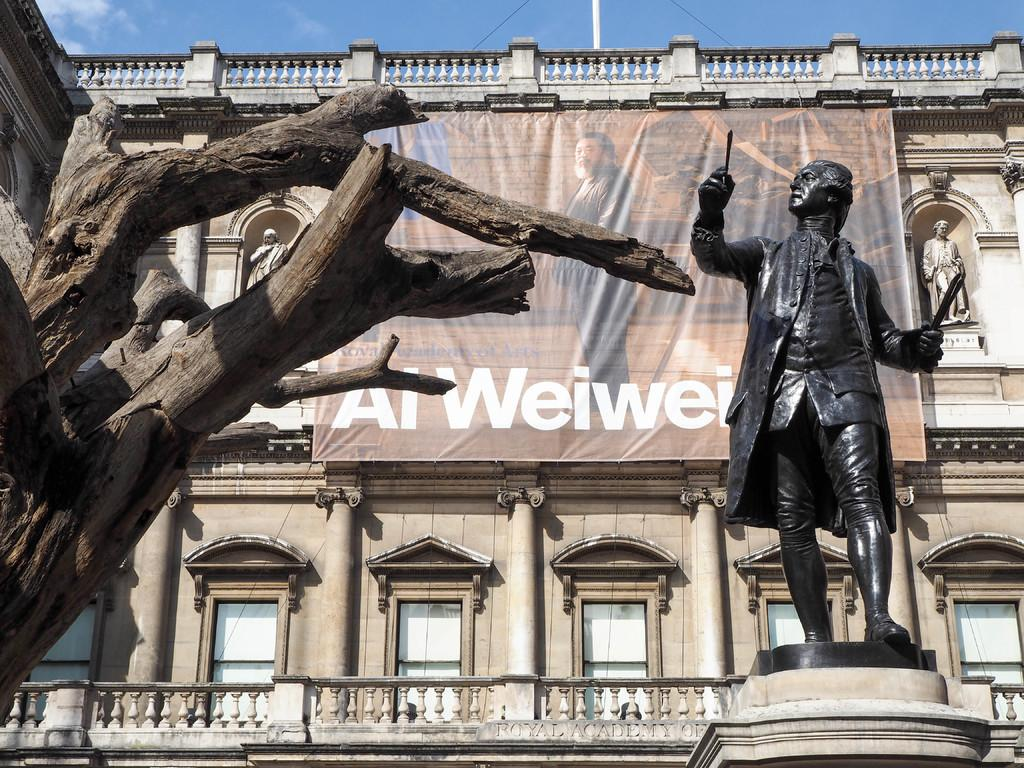<image>
Relay a brief, clear account of the picture shown. Al Weiwei is printed on the bottom of the large banner hanging from the building. 